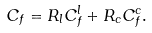<formula> <loc_0><loc_0><loc_500><loc_500>C _ { f } = R _ { l } C _ { f } ^ { l } + R _ { c } C _ { f } ^ { c } .</formula> 